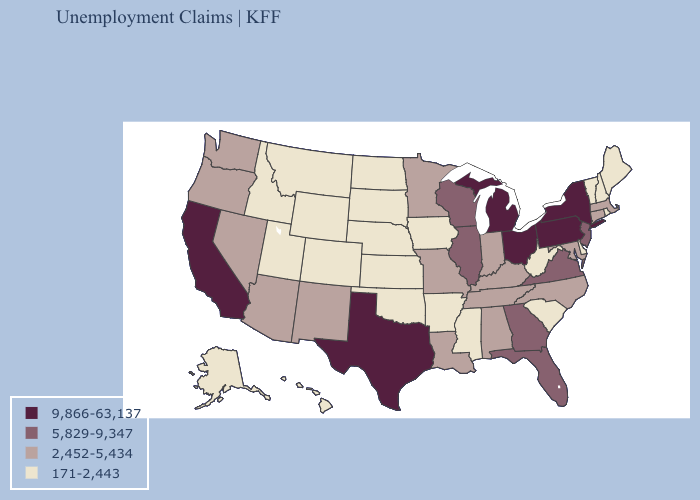Name the states that have a value in the range 9,866-63,137?
Keep it brief. California, Michigan, New York, Ohio, Pennsylvania, Texas. Does Oregon have the same value as Montana?
Answer briefly. No. Which states have the lowest value in the USA?
Give a very brief answer. Alaska, Arkansas, Colorado, Delaware, Hawaii, Idaho, Iowa, Kansas, Maine, Mississippi, Montana, Nebraska, New Hampshire, North Dakota, Oklahoma, Rhode Island, South Carolina, South Dakota, Utah, Vermont, West Virginia, Wyoming. What is the value of Delaware?
Write a very short answer. 171-2,443. What is the value of Ohio?
Be succinct. 9,866-63,137. Name the states that have a value in the range 5,829-9,347?
Concise answer only. Florida, Georgia, Illinois, New Jersey, Virginia, Wisconsin. Does Colorado have the lowest value in the West?
Give a very brief answer. Yes. What is the highest value in the USA?
Short answer required. 9,866-63,137. Does the first symbol in the legend represent the smallest category?
Quick response, please. No. What is the lowest value in states that border Ohio?
Answer briefly. 171-2,443. What is the value of Illinois?
Write a very short answer. 5,829-9,347. What is the value of Vermont?
Quick response, please. 171-2,443. How many symbols are there in the legend?
Write a very short answer. 4. Among the states that border Nevada , which have the lowest value?
Concise answer only. Idaho, Utah. What is the value of Massachusetts?
Keep it brief. 2,452-5,434. 